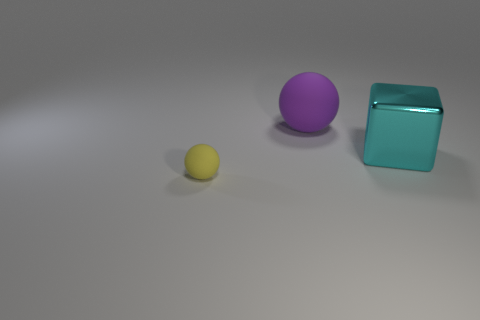Is the thing that is to the right of the big matte thing made of the same material as the purple object?
Provide a succinct answer. No. There is another thing that is the same shape as the small thing; what is its material?
Offer a terse response. Rubber. Is the number of small rubber balls less than the number of large red metal spheres?
Provide a succinct answer. No. There is a matte ball behind the shiny block; does it have the same color as the tiny sphere?
Give a very brief answer. No. The thing that is the same material as the large purple ball is what color?
Offer a terse response. Yellow. Is the size of the yellow sphere the same as the cyan cube?
Keep it short and to the point. No. What is the cyan block made of?
Provide a succinct answer. Metal. What material is the object that is the same size as the cube?
Provide a succinct answer. Rubber. Are there any green rubber balls of the same size as the cyan shiny thing?
Ensure brevity in your answer.  No. Is the number of purple spheres that are in front of the yellow thing the same as the number of purple matte things that are in front of the big rubber object?
Provide a succinct answer. Yes. 